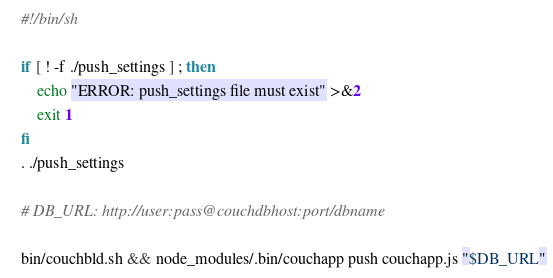Convert code to text. <code><loc_0><loc_0><loc_500><loc_500><_Bash_>#!/bin/sh

if [ ! -f ./push_settings ] ; then
	echo "ERROR: push_settings file must exist" >&2
	exit 1
fi
. ./push_settings

# DB_URL: http://user:pass@couchdbhost:port/dbname

bin/couchbld.sh && node_modules/.bin/couchapp push couchapp.js "$DB_URL"
</code> 